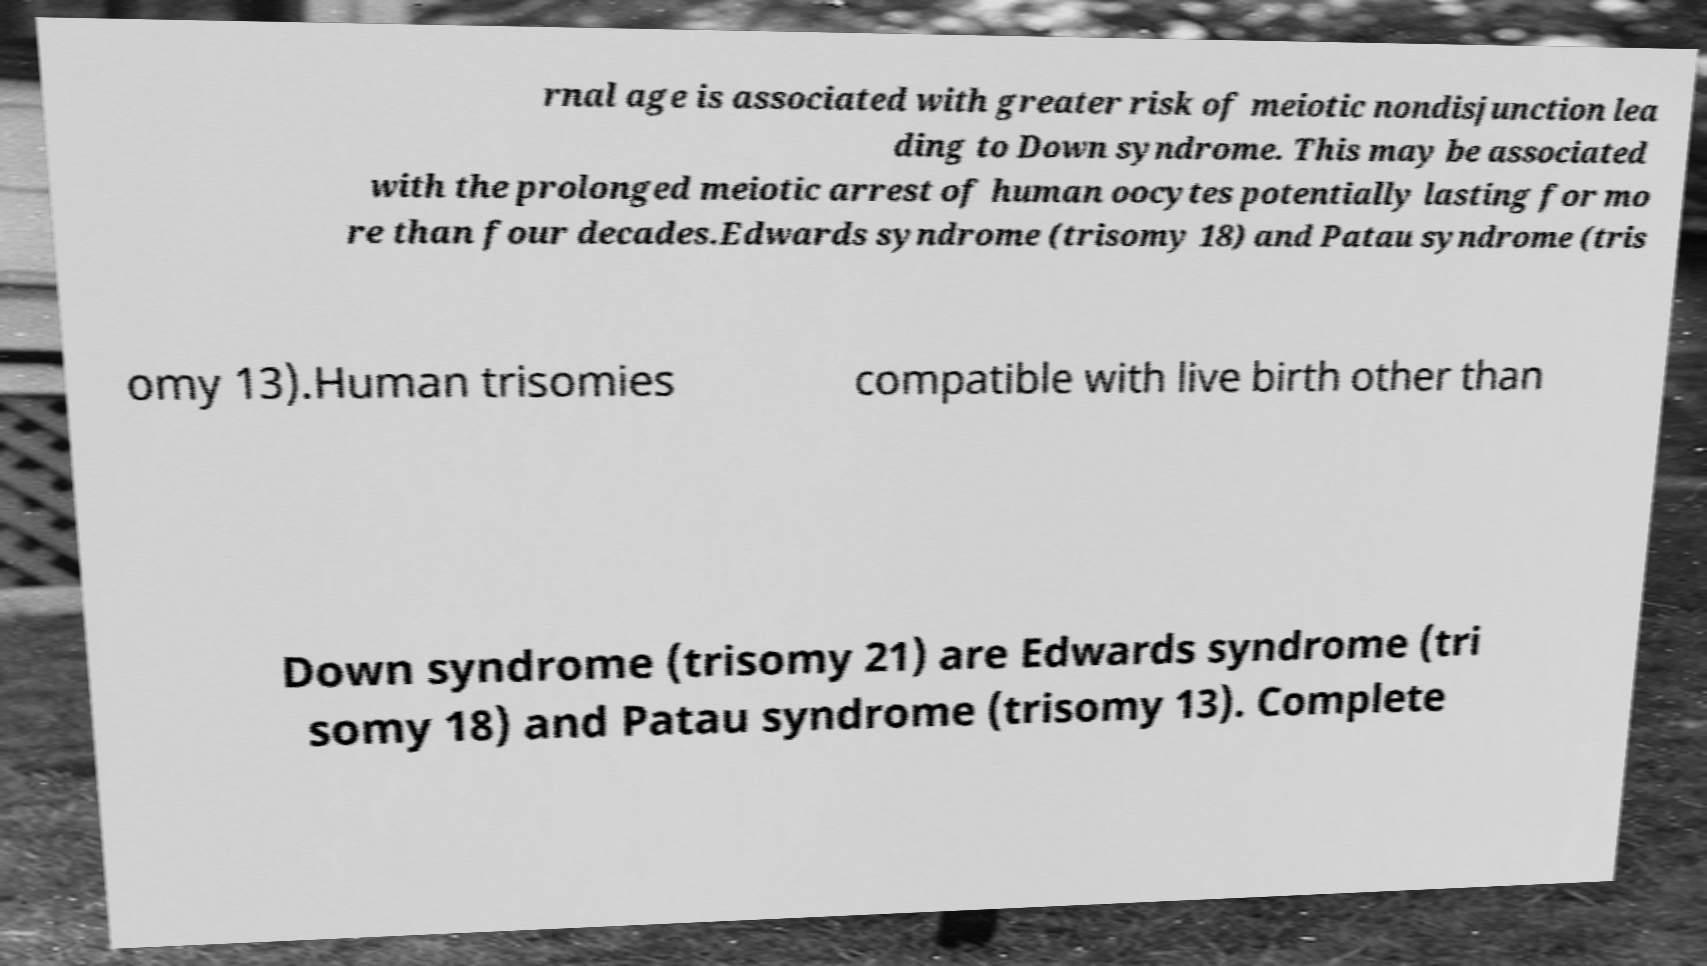For documentation purposes, I need the text within this image transcribed. Could you provide that? rnal age is associated with greater risk of meiotic nondisjunction lea ding to Down syndrome. This may be associated with the prolonged meiotic arrest of human oocytes potentially lasting for mo re than four decades.Edwards syndrome (trisomy 18) and Patau syndrome (tris omy 13).Human trisomies compatible with live birth other than Down syndrome (trisomy 21) are Edwards syndrome (tri somy 18) and Patau syndrome (trisomy 13). Complete 